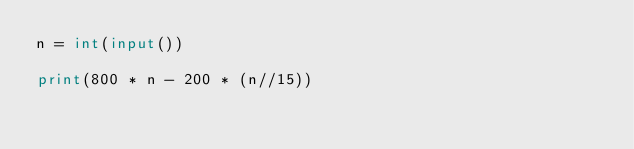<code> <loc_0><loc_0><loc_500><loc_500><_Python_>n = int(input())

print(800 * n - 200 * (n//15))</code> 